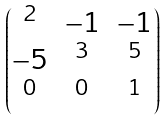<formula> <loc_0><loc_0><loc_500><loc_500>\begin{pmatrix} ^ { 2 } & - 1 & - 1 \\ - 5 & ^ { 3 } & ^ { 5 } \\ ^ { 0 } & ^ { 0 } & ^ { 1 } \end{pmatrix}</formula> 